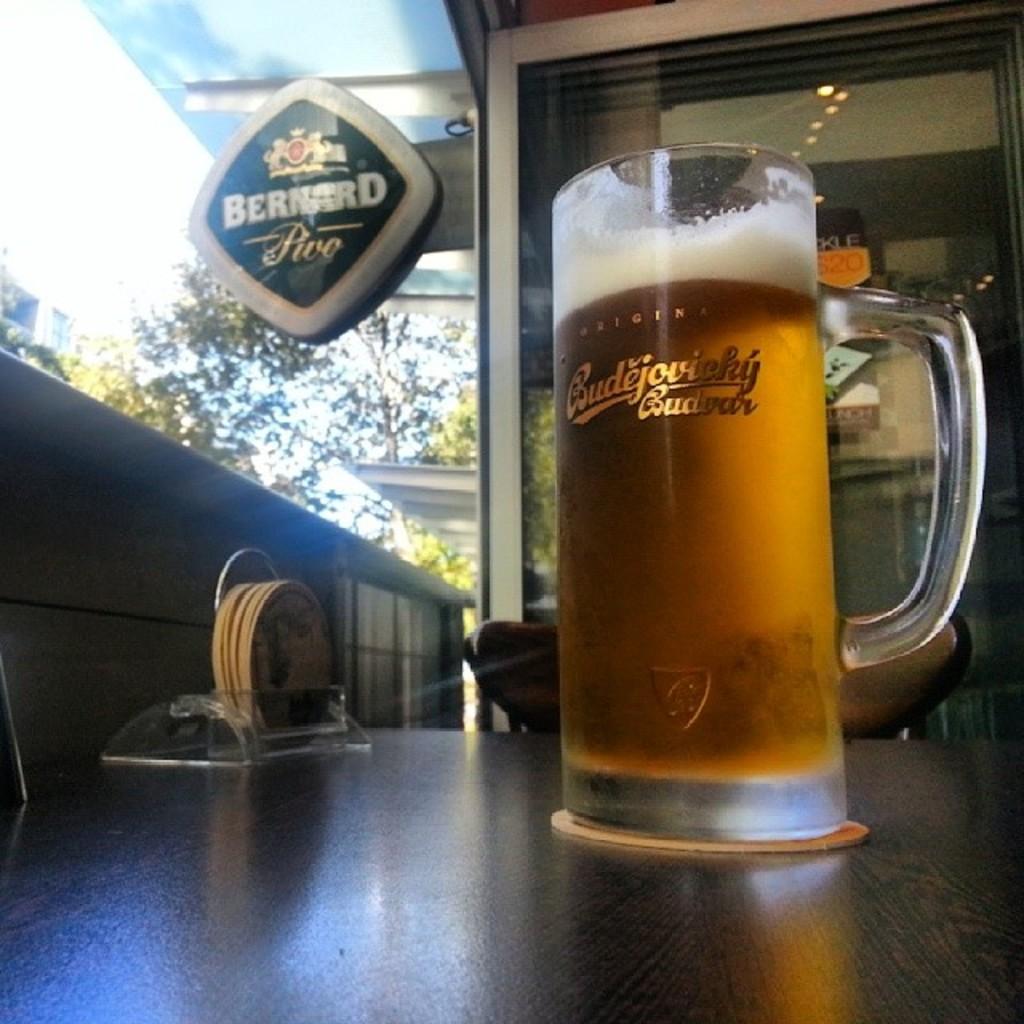What kind of beer is this?
Provide a short and direct response. Unanswerable. 